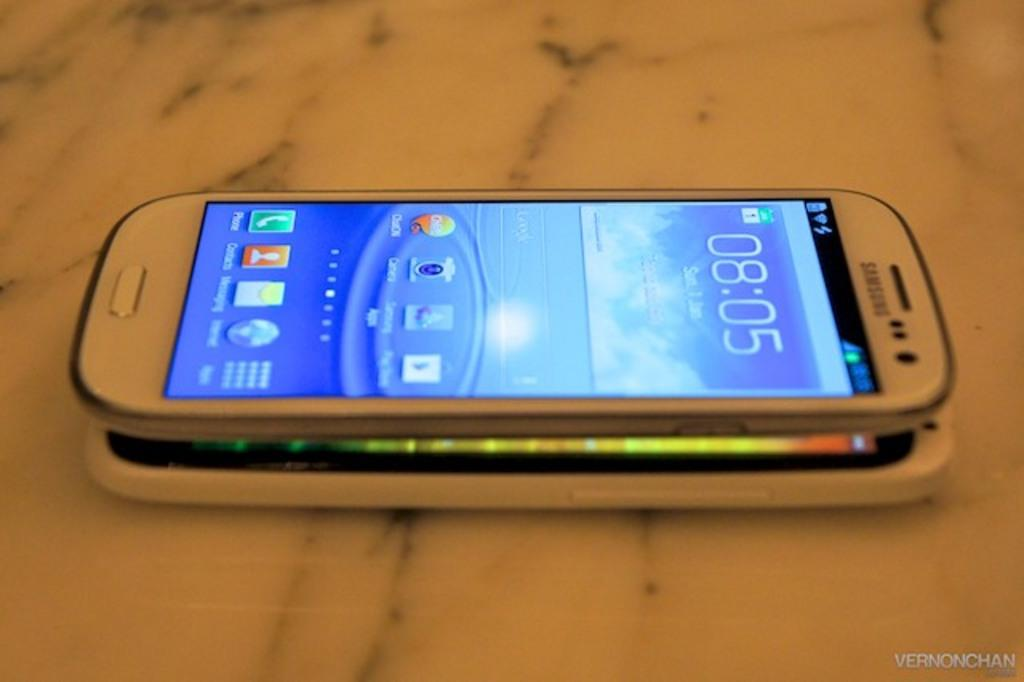<image>
Describe the image concisely. A smart phone is stacked on top of another smart phone at 8:05. 